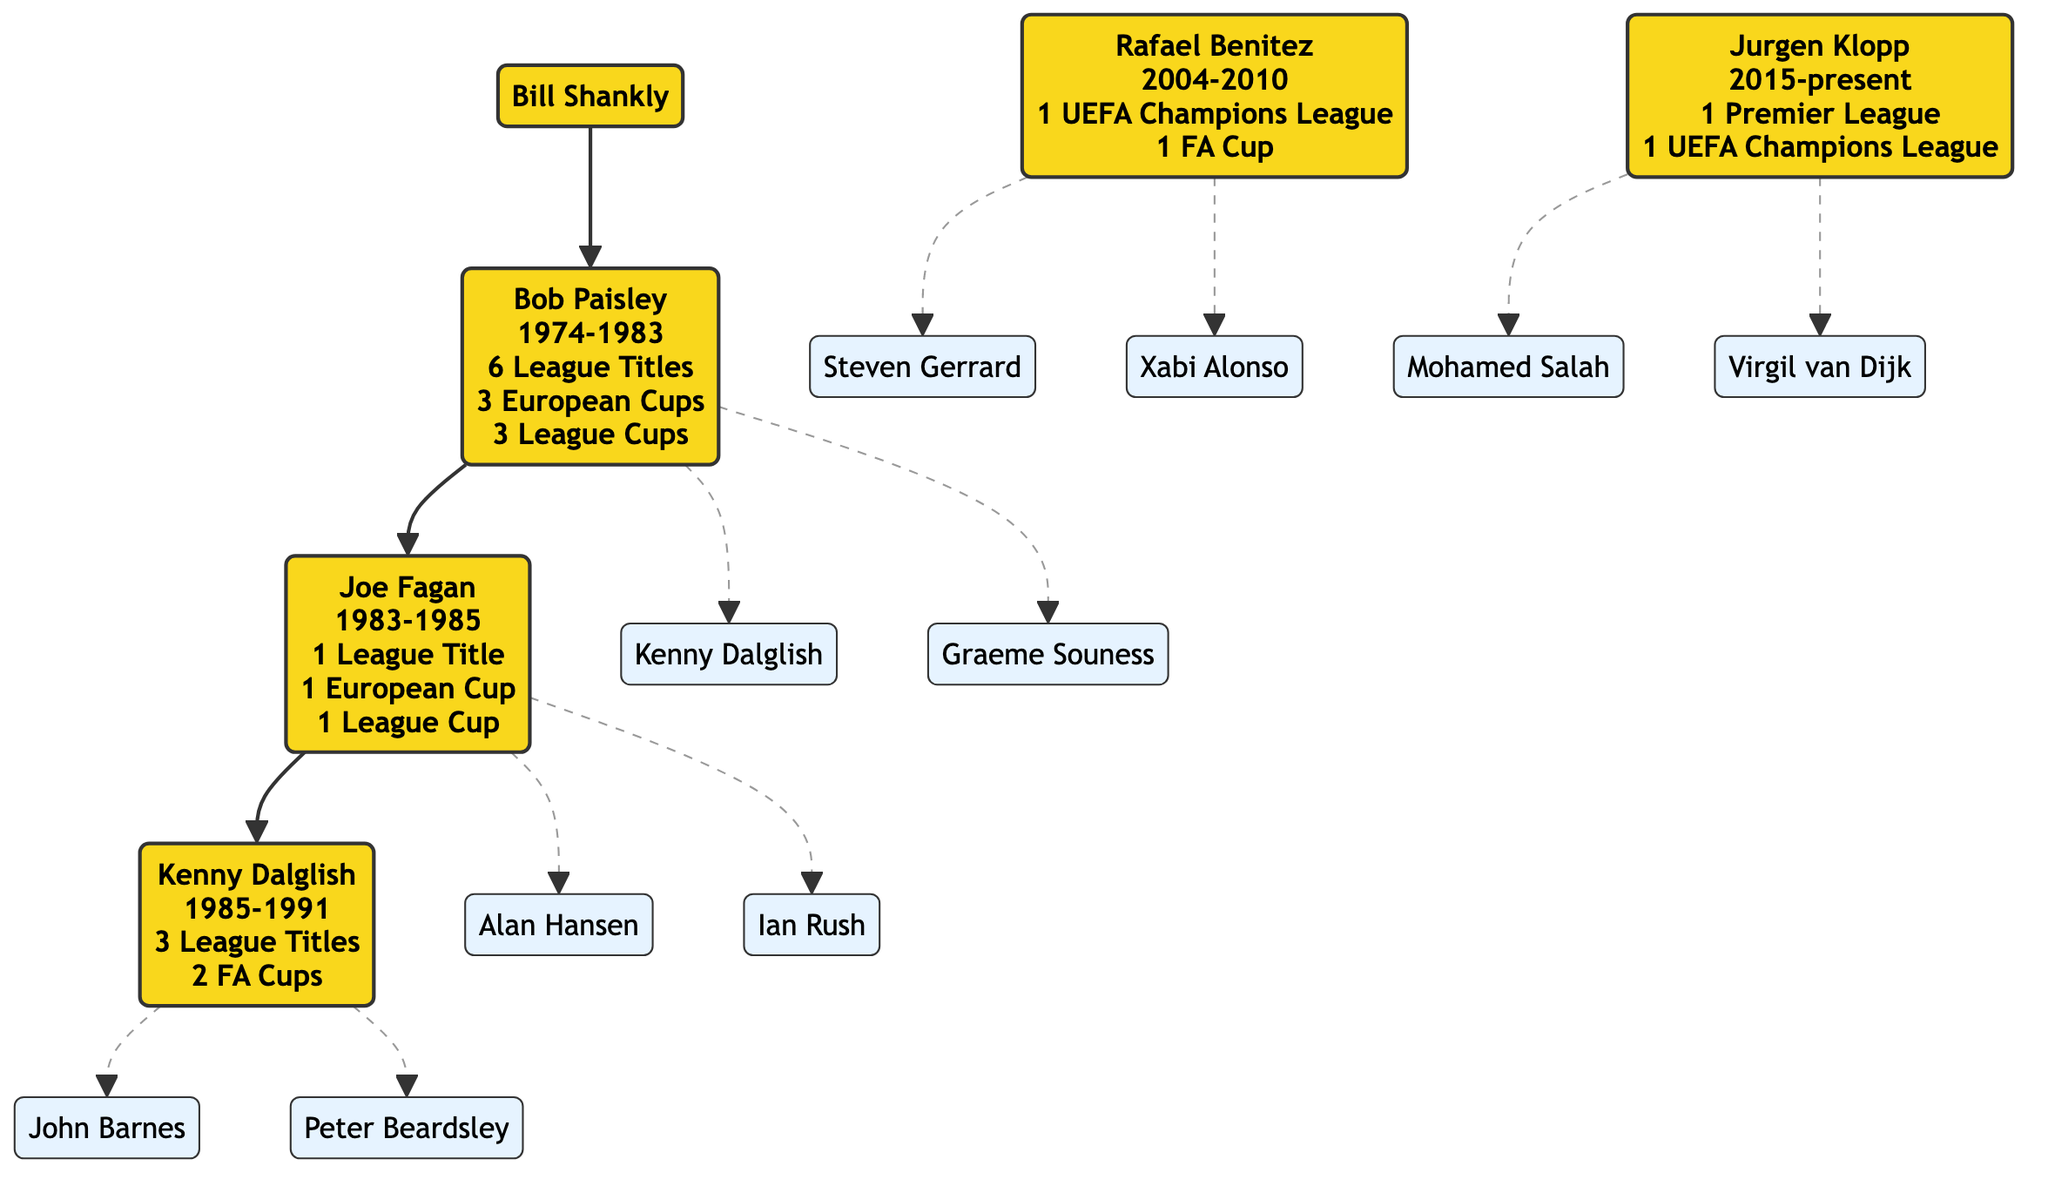What are the achievements of Bob Paisley? The diagram indicates that Bob Paisley achieved "6 League Titles", "3 European Cups", and "3 League Cups".
Answer: 6 League Titles, 3 European Cups, 3 League Cups How many managers preceded Rafael Benitez? By tracing the lineage, Bob Paisley, Joe Fagan, and Kenny Dalglish are the three managers before Rafael Benitez.
Answer: 3 Who succeeded Joe Fagan? The diagram shows that Kenny Dalglish succeeded Joe Fagan.
Answer: Kenny Dalglish Which notable player did Rafael Benitez mentor? According to the diagram, Rafael Benitez mentored notable players like "Steven Gerrard" and "Xabi Alonso"; one of the answers can be "Steven Gerrard".
Answer: Steven Gerrard Who were the two players mentored by Kenny Dalglish? The diagram lists "John Barnes" and "Peter Beardsley" as the notable players mentored by Kenny Dalglish.
Answer: John Barnes, Peter Beardsley How many UEFA Champions League titles did Jurgen Klopp achieve? The diagram states that Jurgen Klopp achieved "1 UEFA Champions League".
Answer: 1 UEFA Champions League Which coach has the most League Titles listed? By reviewing the diagram, Bob Paisley has "6 League Titles", which is more than any other listed coach.
Answer: Bob Paisley Which coach is directly mentored by Bill Shankly? The diagram indicates that Bob Paisley is directly mentored by Bill Shankly.
Answer: Bob Paisley What is the tenure of Joe Fagan? The diagram shows that Joe Fagan's tenure was from "1983-1985".
Answer: 1983-1985 